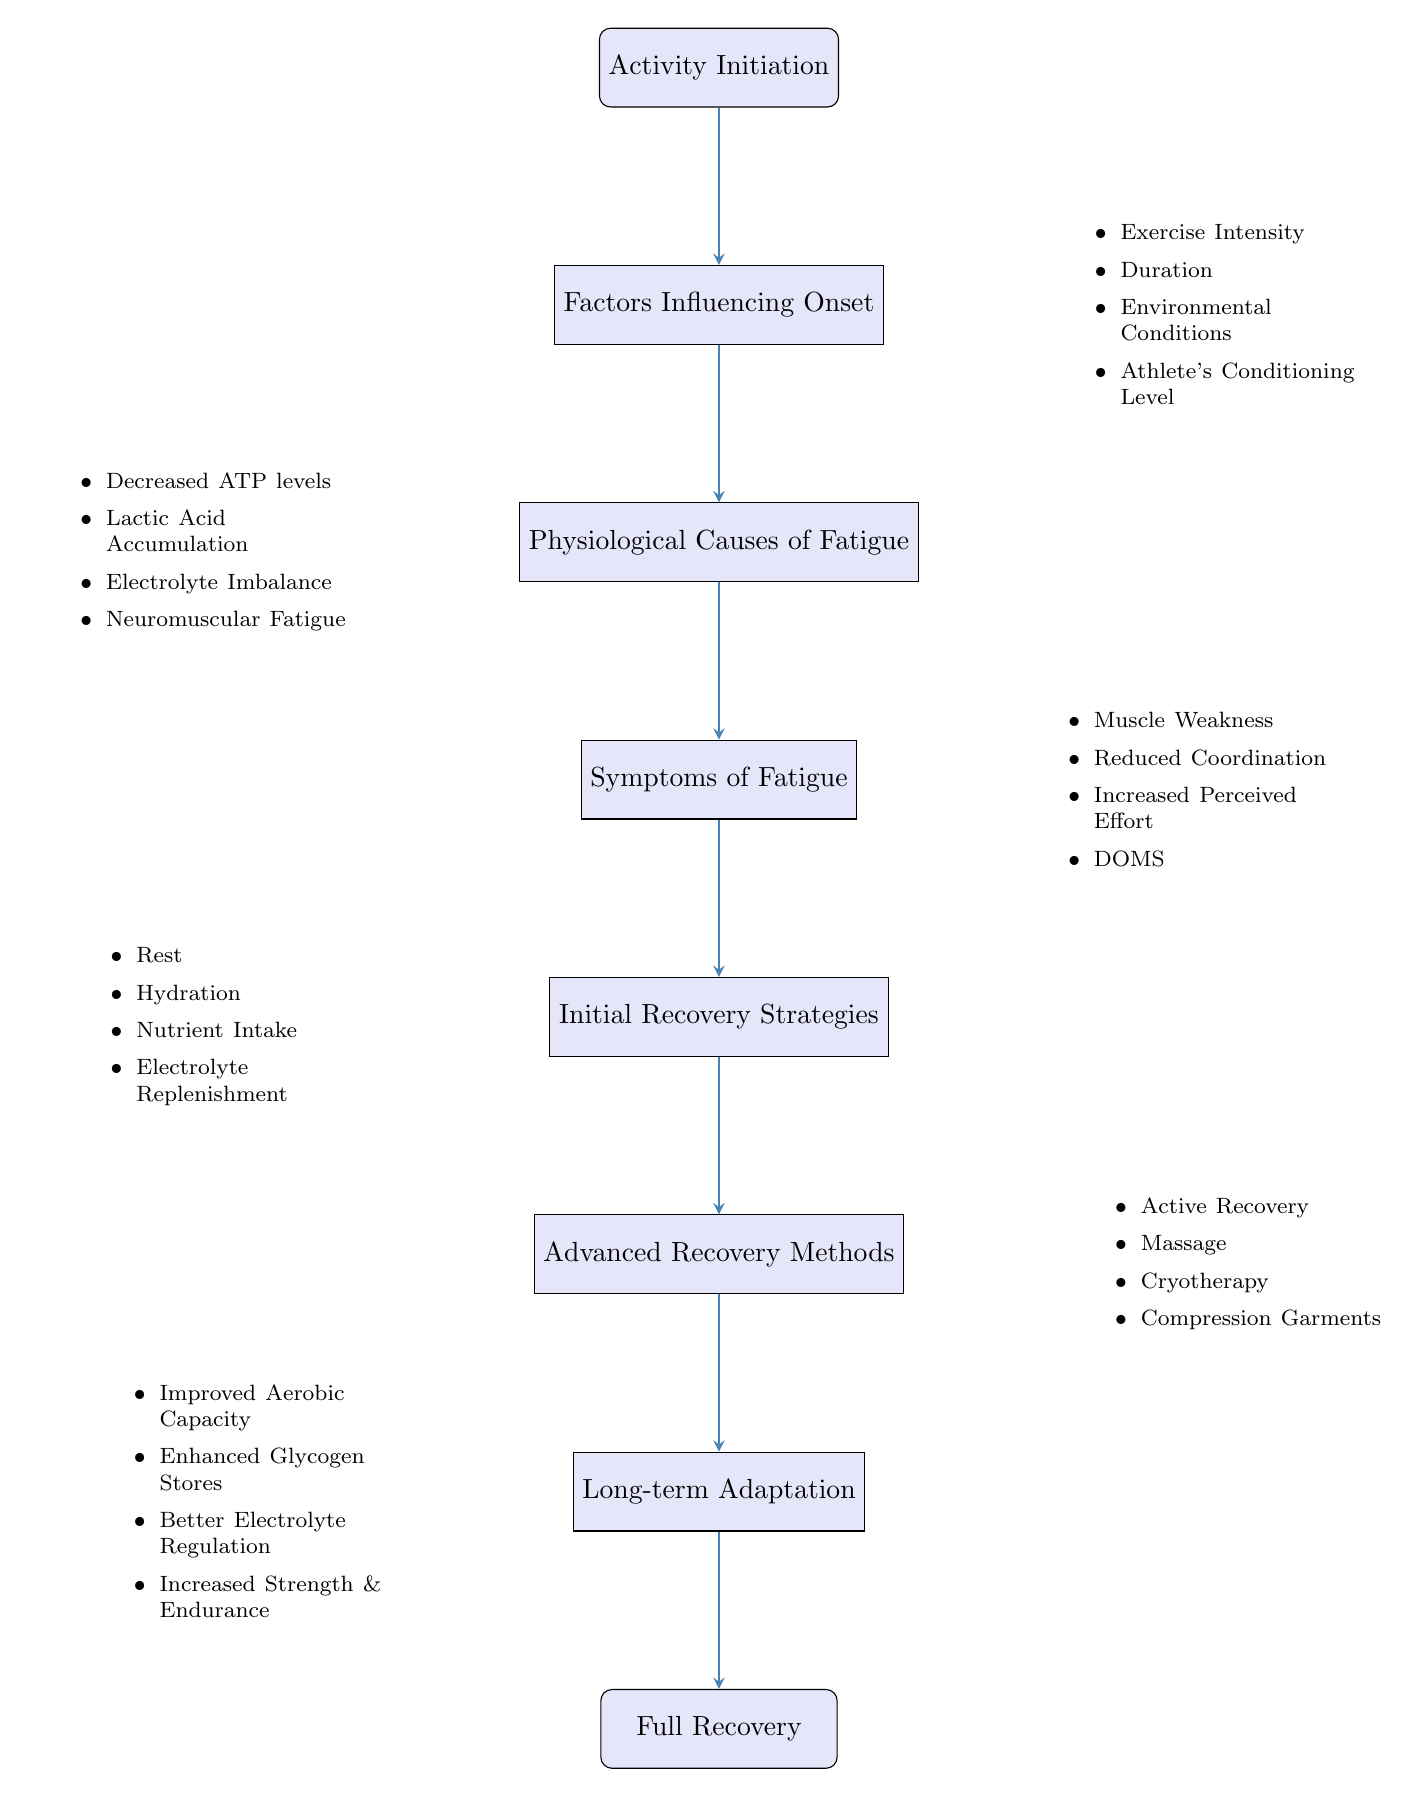What is the first step in the diagram? The diagram begins with "Activity Initiation," which is indicated as the starting point before any other factors or elements are introduced.
Answer: Activity Initiation How many factors influence the onset of muscle fatigue? The diagram lists four factors influencing the onset of muscle fatigue, indicated in the node connected to "Factors Influencing Onset."
Answer: Four What are the physiological causes listed for fatigue? The diagram specifically enumerates four causes of fatigue in the node labeled "Physiological Causes of Fatigue," which provide insight into the underlying issues.
Answer: Decreased ATP levels, Lactic Acid Accumulation, Electrolyte Imbalance, Neuromuscular Fatigue What do the symptoms of fatigue include? The diagram details four specific symptoms under the node "Symptoms of Fatigue," showing the outcomes experienced by athletes.
Answer: Muscle Weakness, Reduced Coordination, Increased Perceived Effort, Delayed Onset Muscle Soreness What is the last stage before "Full Recovery"? The diagram indicates "Long-term Adaptation" as the final step before reaching "Full Recovery," highlighting the benefits that an athlete experiences after recovery.
Answer: Long-term Adaptation How do initial recovery strategies help following fatigue? The node "Initial Recovery Strategies" outlines various strategies that help alleviate fatigue symptoms and promote recovery, which ensures athletes can begin to recuperate.
Answer: Rest, Hydration, Nutrient Intake, Electrolyte Replenishment What connections exist between symptoms and initial recovery strategies? The flow from "Symptoms of Fatigue" to "Initial Recovery Strategies" illustrates that recognizing these symptoms leads directly to employing strategies for recovery. The implication is that addressing symptoms is necessary before recovery can begin.
Answer: Symptoms leads to Initial Recovery Strategies What advanced methods are suggested for recovery? The diagram establishes a clear distinction between initial and advanced recovery methods, listing four specific techniques that are considered more comprehensive approaches to recovery and muscle recovery enhancement.
Answer: Active Recovery, Massage, Cryotherapy, Compression Garments What are the outcomes of long-term adaptation after recovery? The node "Long-term Adaptation" provides insights into the beneficial physiological changes that result from proper recovery practices; they enhance performance and resilience in athletes.
Answer: Improved Aerobic Capacity, Enhanced Muscle Glycogen Stores, Better Electrolyte Regulation, Increased Muscle Strength and Endurance 